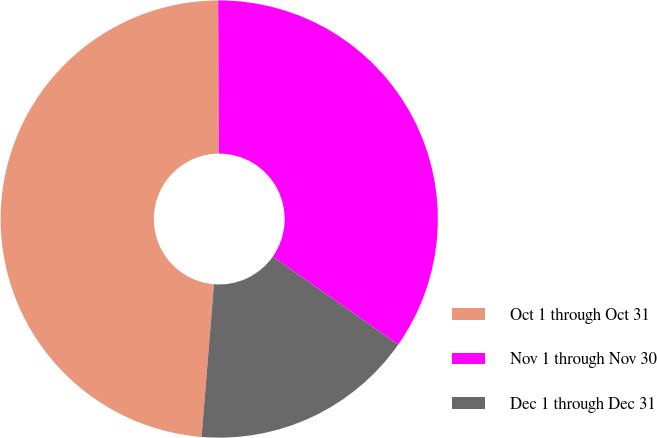Convert chart to OTSL. <chart><loc_0><loc_0><loc_500><loc_500><pie_chart><fcel>Oct 1 through Oct 31<fcel>Nov 1 through Nov 30<fcel>Dec 1 through Dec 31<nl><fcel>48.63%<fcel>34.82%<fcel>16.55%<nl></chart> 